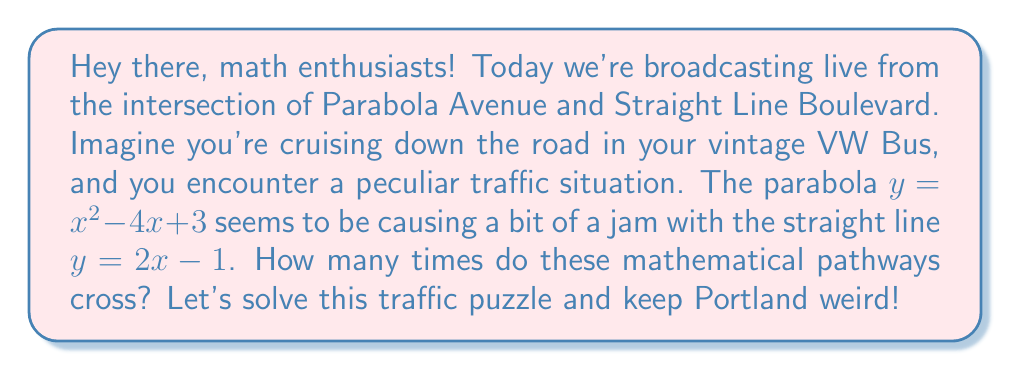Give your solution to this math problem. Alright, let's break this down step-by-step:

1) To find the intersections, we need to set the equations equal to each other:
   $x^2 - 4x + 3 = 2x - 1$

2) Rearrange the equation to standard form:
   $x^2 - 6x + 4 = 0$

3) This is a quadratic equation. We can solve it using the quadratic formula:
   $x = \frac{-b \pm \sqrt{b^2 - 4ac}}{2a}$

   Where $a = 1$, $b = -6$, and $c = 4$

4) Let's plug these values into the formula:
   $x = \frac{6 \pm \sqrt{(-6)^2 - 4(1)(4)}}{2(1)}$

5) Simplify:
   $x = \frac{6 \pm \sqrt{36 - 16}}{2} = \frac{6 \pm \sqrt{20}}{2} = \frac{6 \pm 2\sqrt{5}}{2}$

6) This gives us two solutions:
   $x_1 = \frac{6 + 2\sqrt{5}}{2} = 3 + \sqrt{5}$
   $x_2 = \frac{6 - 2\sqrt{5}}{2} = 3 - \sqrt{5}$

7) Since we have two distinct solutions, the parabola and the line intersect at two points.

[asy]
import graph;
size(200);
real f(real x) {return x^2 - 4x + 3;}
real g(real x) {return 2x - 1;}
draw(graph(f,-1,5), blue);
draw(graph(g,-1,5), red);
dot((3-sqrt(5),f(3-sqrt(5))), green);
dot((3+sqrt(5),f(3+sqrt(5))), green);
xaxis("x");
yaxis("y");
[/asy]
Answer: 2 intersections 